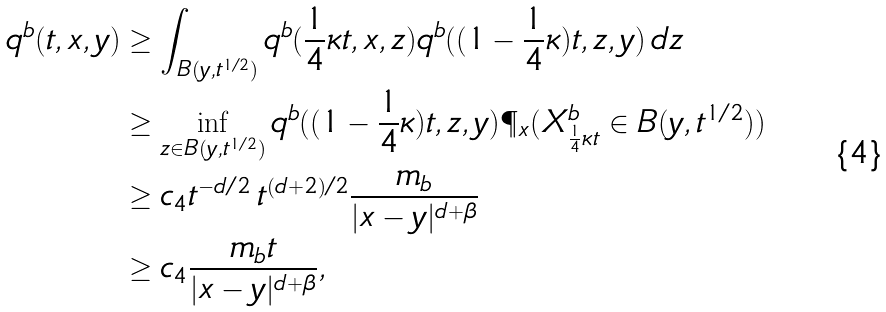<formula> <loc_0><loc_0><loc_500><loc_500>q ^ { b } ( t , x , y ) & \geq \int _ { B ( y , t ^ { 1 / 2 } ) } q ^ { b } ( \frac { 1 } { 4 } \kappa t , x , z ) q ^ { b } ( ( 1 - \frac { 1 } { 4 } \kappa ) t , z , y ) \, d z \\ & \geq \inf _ { z \in B ( y , t ^ { 1 / 2 } ) } q ^ { b } ( ( 1 - \frac { 1 } { 4 } \kappa ) t , z , y ) \P _ { x } ( X ^ { b } _ { \frac { 1 } { 4 } \kappa t } \in B ( y , t ^ { 1 / 2 } ) ) \\ & \geq c _ { 4 } t ^ { - d / 2 } \, t ^ { ( d + 2 ) / 2 } \frac { m _ { b } } { | x - y | ^ { d + \beta } } \\ & \geq c _ { 4 } \frac { m _ { b } t } { | x - y | ^ { d + \beta } } ,</formula> 